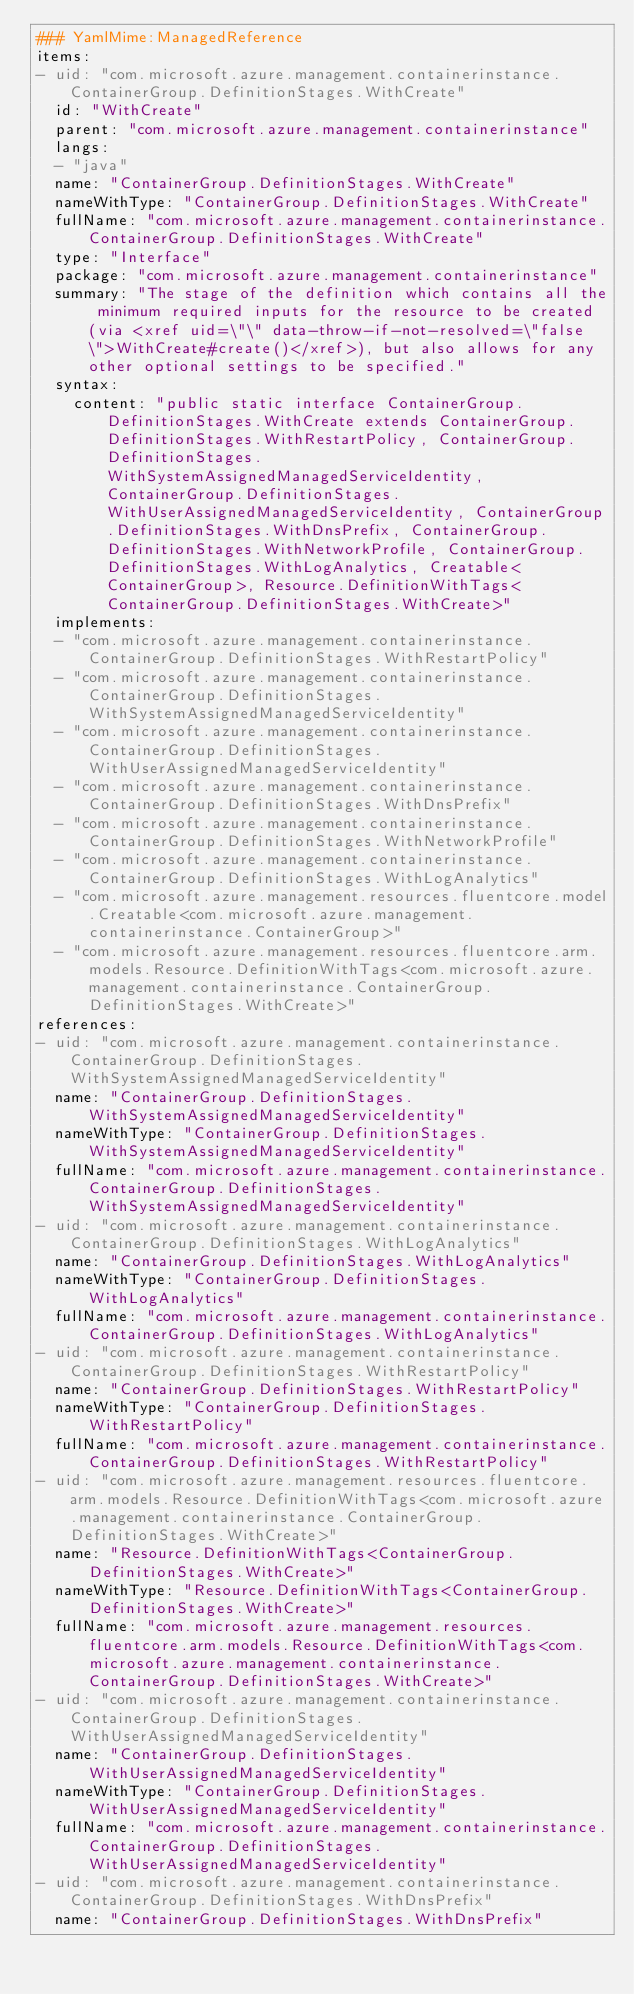<code> <loc_0><loc_0><loc_500><loc_500><_YAML_>### YamlMime:ManagedReference
items:
- uid: "com.microsoft.azure.management.containerinstance.ContainerGroup.DefinitionStages.WithCreate"
  id: "WithCreate"
  parent: "com.microsoft.azure.management.containerinstance"
  langs:
  - "java"
  name: "ContainerGroup.DefinitionStages.WithCreate"
  nameWithType: "ContainerGroup.DefinitionStages.WithCreate"
  fullName: "com.microsoft.azure.management.containerinstance.ContainerGroup.DefinitionStages.WithCreate"
  type: "Interface"
  package: "com.microsoft.azure.management.containerinstance"
  summary: "The stage of the definition which contains all the minimum required inputs for the resource to be created (via <xref uid=\"\" data-throw-if-not-resolved=\"false\">WithCreate#create()</xref>), but also allows for any other optional settings to be specified."
  syntax:
    content: "public static interface ContainerGroup.DefinitionStages.WithCreate extends ContainerGroup.DefinitionStages.WithRestartPolicy, ContainerGroup.DefinitionStages.WithSystemAssignedManagedServiceIdentity, ContainerGroup.DefinitionStages.WithUserAssignedManagedServiceIdentity, ContainerGroup.DefinitionStages.WithDnsPrefix, ContainerGroup.DefinitionStages.WithNetworkProfile, ContainerGroup.DefinitionStages.WithLogAnalytics, Creatable<ContainerGroup>, Resource.DefinitionWithTags<ContainerGroup.DefinitionStages.WithCreate>"
  implements:
  - "com.microsoft.azure.management.containerinstance.ContainerGroup.DefinitionStages.WithRestartPolicy"
  - "com.microsoft.azure.management.containerinstance.ContainerGroup.DefinitionStages.WithSystemAssignedManagedServiceIdentity"
  - "com.microsoft.azure.management.containerinstance.ContainerGroup.DefinitionStages.WithUserAssignedManagedServiceIdentity"
  - "com.microsoft.azure.management.containerinstance.ContainerGroup.DefinitionStages.WithDnsPrefix"
  - "com.microsoft.azure.management.containerinstance.ContainerGroup.DefinitionStages.WithNetworkProfile"
  - "com.microsoft.azure.management.containerinstance.ContainerGroup.DefinitionStages.WithLogAnalytics"
  - "com.microsoft.azure.management.resources.fluentcore.model.Creatable<com.microsoft.azure.management.containerinstance.ContainerGroup>"
  - "com.microsoft.azure.management.resources.fluentcore.arm.models.Resource.DefinitionWithTags<com.microsoft.azure.management.containerinstance.ContainerGroup.DefinitionStages.WithCreate>"
references:
- uid: "com.microsoft.azure.management.containerinstance.ContainerGroup.DefinitionStages.WithSystemAssignedManagedServiceIdentity"
  name: "ContainerGroup.DefinitionStages.WithSystemAssignedManagedServiceIdentity"
  nameWithType: "ContainerGroup.DefinitionStages.WithSystemAssignedManagedServiceIdentity"
  fullName: "com.microsoft.azure.management.containerinstance.ContainerGroup.DefinitionStages.WithSystemAssignedManagedServiceIdentity"
- uid: "com.microsoft.azure.management.containerinstance.ContainerGroup.DefinitionStages.WithLogAnalytics"
  name: "ContainerGroup.DefinitionStages.WithLogAnalytics"
  nameWithType: "ContainerGroup.DefinitionStages.WithLogAnalytics"
  fullName: "com.microsoft.azure.management.containerinstance.ContainerGroup.DefinitionStages.WithLogAnalytics"
- uid: "com.microsoft.azure.management.containerinstance.ContainerGroup.DefinitionStages.WithRestartPolicy"
  name: "ContainerGroup.DefinitionStages.WithRestartPolicy"
  nameWithType: "ContainerGroup.DefinitionStages.WithRestartPolicy"
  fullName: "com.microsoft.azure.management.containerinstance.ContainerGroup.DefinitionStages.WithRestartPolicy"
- uid: "com.microsoft.azure.management.resources.fluentcore.arm.models.Resource.DefinitionWithTags<com.microsoft.azure.management.containerinstance.ContainerGroup.DefinitionStages.WithCreate>"
  name: "Resource.DefinitionWithTags<ContainerGroup.DefinitionStages.WithCreate>"
  nameWithType: "Resource.DefinitionWithTags<ContainerGroup.DefinitionStages.WithCreate>"
  fullName: "com.microsoft.azure.management.resources.fluentcore.arm.models.Resource.DefinitionWithTags<com.microsoft.azure.management.containerinstance.ContainerGroup.DefinitionStages.WithCreate>"
- uid: "com.microsoft.azure.management.containerinstance.ContainerGroup.DefinitionStages.WithUserAssignedManagedServiceIdentity"
  name: "ContainerGroup.DefinitionStages.WithUserAssignedManagedServiceIdentity"
  nameWithType: "ContainerGroup.DefinitionStages.WithUserAssignedManagedServiceIdentity"
  fullName: "com.microsoft.azure.management.containerinstance.ContainerGroup.DefinitionStages.WithUserAssignedManagedServiceIdentity"
- uid: "com.microsoft.azure.management.containerinstance.ContainerGroup.DefinitionStages.WithDnsPrefix"
  name: "ContainerGroup.DefinitionStages.WithDnsPrefix"</code> 